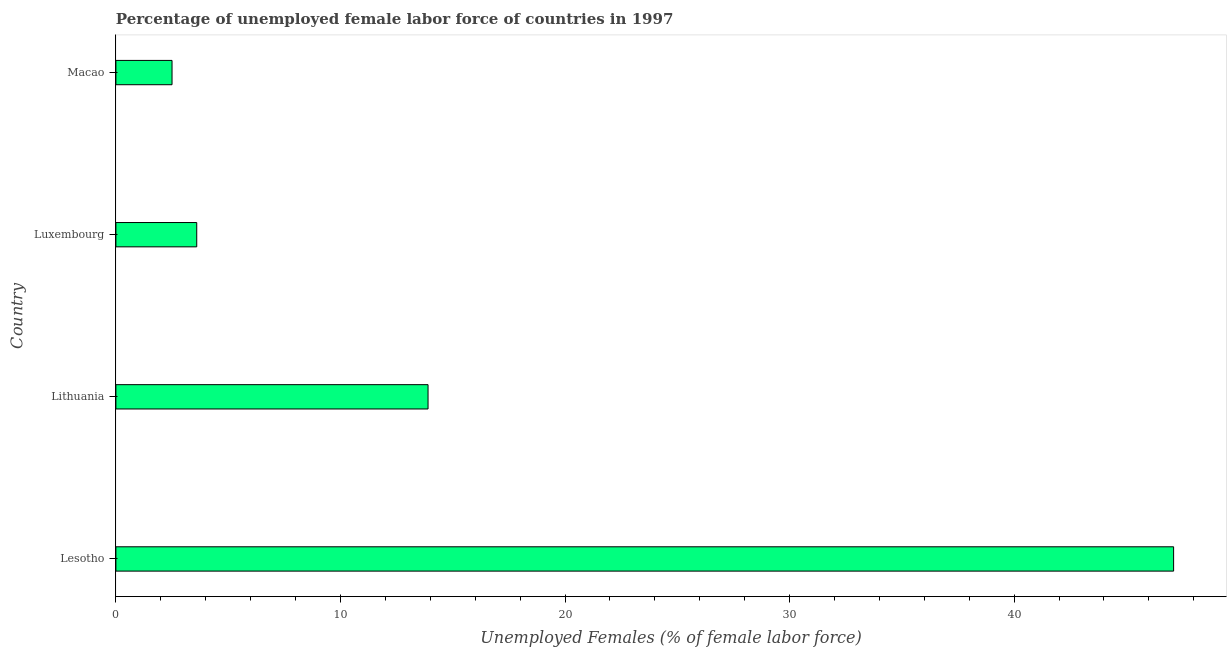Does the graph contain any zero values?
Give a very brief answer. No. What is the title of the graph?
Make the answer very short. Percentage of unemployed female labor force of countries in 1997. What is the label or title of the X-axis?
Keep it short and to the point. Unemployed Females (% of female labor force). What is the label or title of the Y-axis?
Your response must be concise. Country. What is the total unemployed female labour force in Lesotho?
Offer a terse response. 47.1. Across all countries, what is the maximum total unemployed female labour force?
Ensure brevity in your answer.  47.1. In which country was the total unemployed female labour force maximum?
Provide a short and direct response. Lesotho. In which country was the total unemployed female labour force minimum?
Make the answer very short. Macao. What is the sum of the total unemployed female labour force?
Your answer should be very brief. 67.1. What is the difference between the total unemployed female labour force in Lithuania and Luxembourg?
Your response must be concise. 10.3. What is the average total unemployed female labour force per country?
Offer a very short reply. 16.77. What is the median total unemployed female labour force?
Give a very brief answer. 8.75. What is the ratio of the total unemployed female labour force in Lesotho to that in Luxembourg?
Offer a very short reply. 13.08. Is the total unemployed female labour force in Luxembourg less than that in Macao?
Keep it short and to the point. No. What is the difference between the highest and the second highest total unemployed female labour force?
Make the answer very short. 33.2. Is the sum of the total unemployed female labour force in Lithuania and Luxembourg greater than the maximum total unemployed female labour force across all countries?
Keep it short and to the point. No. What is the difference between the highest and the lowest total unemployed female labour force?
Ensure brevity in your answer.  44.6. What is the difference between two consecutive major ticks on the X-axis?
Your answer should be very brief. 10. Are the values on the major ticks of X-axis written in scientific E-notation?
Your answer should be compact. No. What is the Unemployed Females (% of female labor force) in Lesotho?
Offer a very short reply. 47.1. What is the Unemployed Females (% of female labor force) in Lithuania?
Your response must be concise. 13.9. What is the Unemployed Females (% of female labor force) in Luxembourg?
Your answer should be very brief. 3.6. What is the Unemployed Females (% of female labor force) in Macao?
Give a very brief answer. 2.5. What is the difference between the Unemployed Females (% of female labor force) in Lesotho and Lithuania?
Make the answer very short. 33.2. What is the difference between the Unemployed Females (% of female labor force) in Lesotho and Luxembourg?
Your response must be concise. 43.5. What is the difference between the Unemployed Females (% of female labor force) in Lesotho and Macao?
Give a very brief answer. 44.6. What is the difference between the Unemployed Females (% of female labor force) in Lithuania and Luxembourg?
Make the answer very short. 10.3. What is the difference between the Unemployed Females (% of female labor force) in Luxembourg and Macao?
Your answer should be compact. 1.1. What is the ratio of the Unemployed Females (% of female labor force) in Lesotho to that in Lithuania?
Provide a short and direct response. 3.39. What is the ratio of the Unemployed Females (% of female labor force) in Lesotho to that in Luxembourg?
Make the answer very short. 13.08. What is the ratio of the Unemployed Females (% of female labor force) in Lesotho to that in Macao?
Offer a terse response. 18.84. What is the ratio of the Unemployed Females (% of female labor force) in Lithuania to that in Luxembourg?
Your answer should be very brief. 3.86. What is the ratio of the Unemployed Females (% of female labor force) in Lithuania to that in Macao?
Offer a terse response. 5.56. What is the ratio of the Unemployed Females (% of female labor force) in Luxembourg to that in Macao?
Your answer should be compact. 1.44. 